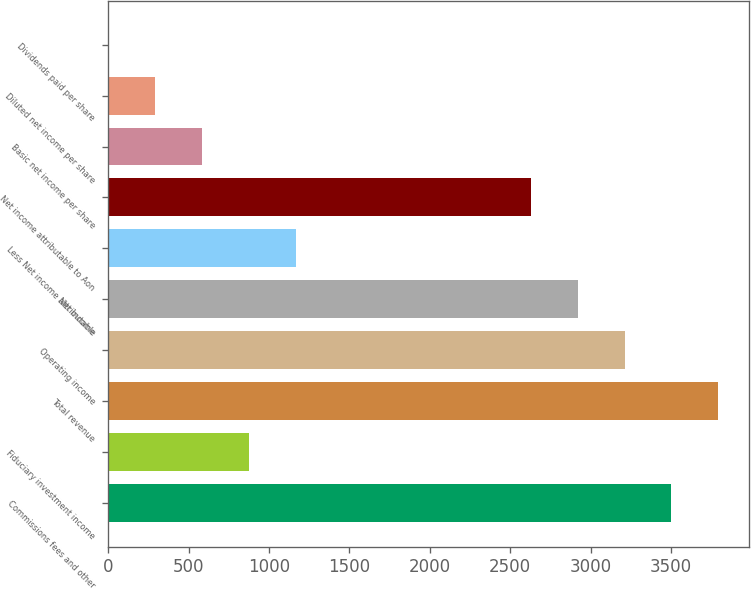Convert chart. <chart><loc_0><loc_0><loc_500><loc_500><bar_chart><fcel>Commissions fees and other<fcel>Fiduciary investment income<fcel>Total revenue<fcel>Operating income<fcel>Net income<fcel>Less Net income attributable<fcel>Net income attributable to Aon<fcel>Basic net income per share<fcel>Diluted net income per share<fcel>Dividends paid per share<nl><fcel>3502.76<fcel>875.88<fcel>3794.64<fcel>3210.89<fcel>2919.01<fcel>1167.76<fcel>2627.14<fcel>584<fcel>292.12<fcel>0.25<nl></chart> 